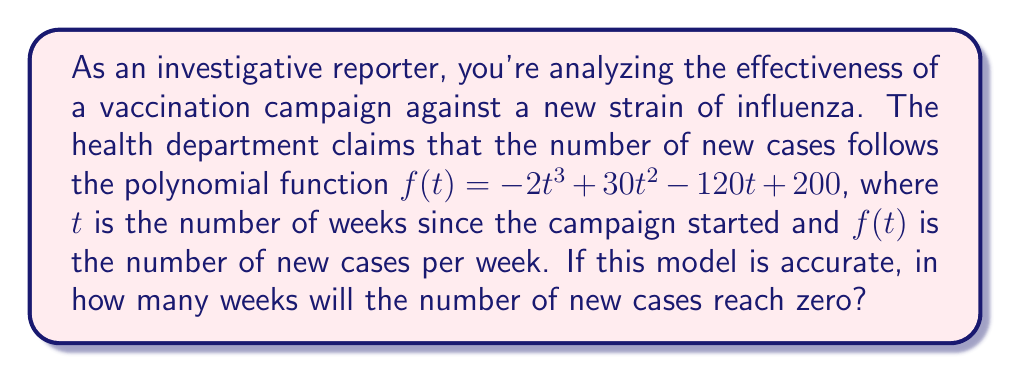What is the answer to this math problem? To solve this problem, we need to find the roots of the polynomial function $f(t) = -2t^3 + 30t^2 - 120t + 200$. The roots of this function will represent the times when the number of new cases is zero.

Steps to solve:

1) First, we need to factor out the greatest common factor (GCF):
   $f(t) = -2(t^3 - 15t^2 + 60t - 100)$

2) Now, we can try to guess one root. By inspection or trial and error, we can find that $t = 5$ is a root.

3) We can divide the polynomial by $(t - 5)$ using polynomial long division:

   $t^3 - 15t^2 + 60t - 100 = (t - 5)(t^2 - 10t + 20)$

4) The quadratic factor $t^2 - 10t + 20$ can be solved using the quadratic formula:

   $t = \frac{-b \pm \sqrt{b^2 - 4ac}}{2a}$

   Where $a = 1$, $b = -10$, and $c = 20$

5) Plugging these values into the quadratic formula:

   $t = \frac{10 \pm \sqrt{100 - 80}}{2} = \frac{10 \pm \sqrt{20}}{2}$

6) Simplifying:

   $t = 5 \pm \sqrt{5}$

7) Therefore, the roots of the original polynomial are:

   $t = 5$, $t = 5 + \sqrt{5}$, and $t = 5 - \sqrt{5}$

8) Since we're looking for when the number of cases will reach zero in the future, we're interested in the largest positive root, which is $5 + \sqrt{5}$.

9) $5 + \sqrt{5} \approx 7.236$ weeks

Since we're dealing with whole weeks, we round up to the nearest whole number.
Answer: The number of new cases will reach zero after 8 weeks. 